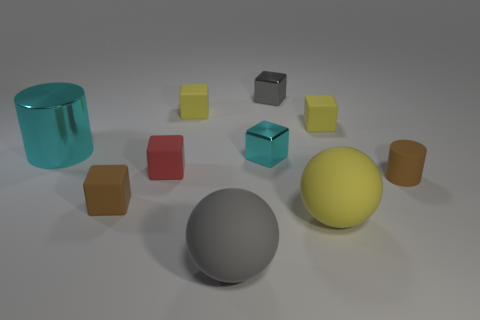Subtract all yellow cubes. How many cubes are left? 4 Subtract all yellow spheres. How many spheres are left? 1 Subtract all spheres. How many objects are left? 8 Subtract 3 cubes. How many cubes are left? 3 Subtract 1 gray balls. How many objects are left? 9 Subtract all yellow cylinders. Subtract all brown cubes. How many cylinders are left? 2 Subtract all blue balls. How many gray cubes are left? 1 Subtract all red rubber blocks. Subtract all small yellow blocks. How many objects are left? 7 Add 4 large shiny cylinders. How many large shiny cylinders are left? 5 Add 9 small cyan shiny cubes. How many small cyan shiny cubes exist? 10 